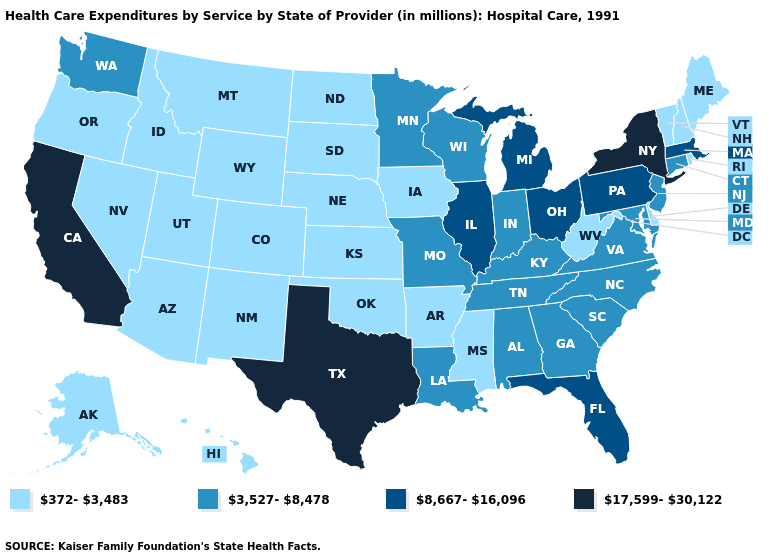Does Alaska have the same value as Massachusetts?
Short answer required. No. What is the highest value in the MidWest ?
Short answer required. 8,667-16,096. Name the states that have a value in the range 17,599-30,122?
Be succinct. California, New York, Texas. Does Colorado have a lower value than Idaho?
Short answer required. No. Does Florida have the same value as Illinois?
Write a very short answer. Yes. What is the highest value in the USA?
Write a very short answer. 17,599-30,122. Which states have the highest value in the USA?
Keep it brief. California, New York, Texas. How many symbols are there in the legend?
Answer briefly. 4. What is the value of Ohio?
Write a very short answer. 8,667-16,096. Name the states that have a value in the range 3,527-8,478?
Short answer required. Alabama, Connecticut, Georgia, Indiana, Kentucky, Louisiana, Maryland, Minnesota, Missouri, New Jersey, North Carolina, South Carolina, Tennessee, Virginia, Washington, Wisconsin. Which states have the highest value in the USA?
Keep it brief. California, New York, Texas. What is the value of Oklahoma?
Concise answer only. 372-3,483. Name the states that have a value in the range 8,667-16,096?
Keep it brief. Florida, Illinois, Massachusetts, Michigan, Ohio, Pennsylvania. What is the value of New Hampshire?
Short answer required. 372-3,483. What is the value of Louisiana?
Quick response, please. 3,527-8,478. 